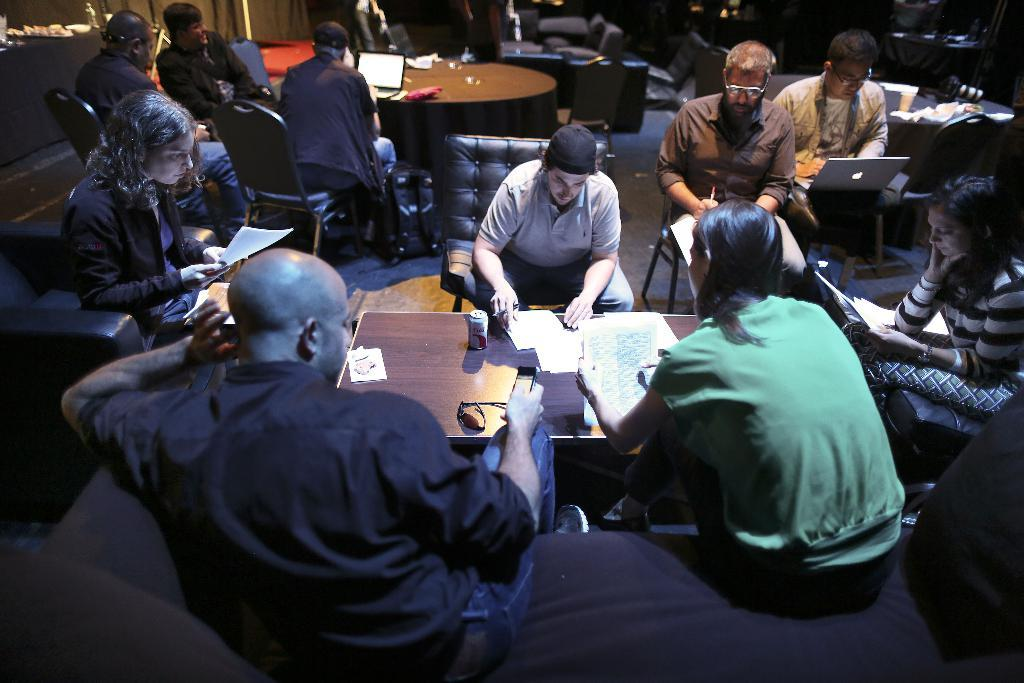What is the main piece of furniture in the image? There is a table in the image. What items can be seen on the table? The table has books and papers on it, as well as other objects. What is the activity of the people in the image? There are people sitting around the table, which suggests they might be engaged in a discussion or working together. Can you describe the people in the background of the image? There are people in the background of the image, but their specific activities or positions cannot be determined from the provided facts. What type of cord is being used by the people sitting around the table? There is no mention of a cord in the image, so it cannot be determined what type of cord might be used. 